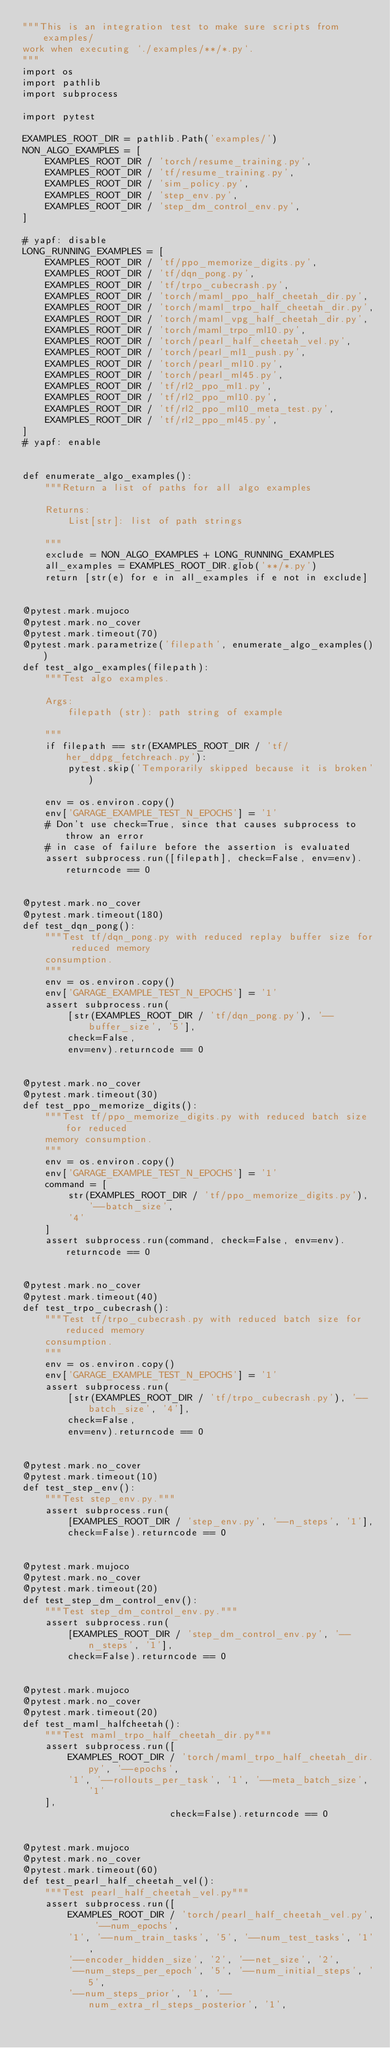<code> <loc_0><loc_0><loc_500><loc_500><_Python_>"""This is an integration test to make sure scripts from examples/
work when executing `./examples/**/*.py`.
"""
import os
import pathlib
import subprocess

import pytest

EXAMPLES_ROOT_DIR = pathlib.Path('examples/')
NON_ALGO_EXAMPLES = [
    EXAMPLES_ROOT_DIR / 'torch/resume_training.py',
    EXAMPLES_ROOT_DIR / 'tf/resume_training.py',
    EXAMPLES_ROOT_DIR / 'sim_policy.py',
    EXAMPLES_ROOT_DIR / 'step_env.py',
    EXAMPLES_ROOT_DIR / 'step_dm_control_env.py',
]

# yapf: disable
LONG_RUNNING_EXAMPLES = [
    EXAMPLES_ROOT_DIR / 'tf/ppo_memorize_digits.py',
    EXAMPLES_ROOT_DIR / 'tf/dqn_pong.py',
    EXAMPLES_ROOT_DIR / 'tf/trpo_cubecrash.py',
    EXAMPLES_ROOT_DIR / 'torch/maml_ppo_half_cheetah_dir.py',
    EXAMPLES_ROOT_DIR / 'torch/maml_trpo_half_cheetah_dir.py',
    EXAMPLES_ROOT_DIR / 'torch/maml_vpg_half_cheetah_dir.py',
    EXAMPLES_ROOT_DIR / 'torch/maml_trpo_ml10.py',
    EXAMPLES_ROOT_DIR / 'torch/pearl_half_cheetah_vel.py',
    EXAMPLES_ROOT_DIR / 'torch/pearl_ml1_push.py',
    EXAMPLES_ROOT_DIR / 'torch/pearl_ml10.py',
    EXAMPLES_ROOT_DIR / 'torch/pearl_ml45.py',
    EXAMPLES_ROOT_DIR / 'tf/rl2_ppo_ml1.py',
    EXAMPLES_ROOT_DIR / 'tf/rl2_ppo_ml10.py',
    EXAMPLES_ROOT_DIR / 'tf/rl2_ppo_ml10_meta_test.py',
    EXAMPLES_ROOT_DIR / 'tf/rl2_ppo_ml45.py',
]
# yapf: enable


def enumerate_algo_examples():
    """Return a list of paths for all algo examples

    Returns:
        List[str]: list of path strings

    """
    exclude = NON_ALGO_EXAMPLES + LONG_RUNNING_EXAMPLES
    all_examples = EXAMPLES_ROOT_DIR.glob('**/*.py')
    return [str(e) for e in all_examples if e not in exclude]


@pytest.mark.mujoco
@pytest.mark.no_cover
@pytest.mark.timeout(70)
@pytest.mark.parametrize('filepath', enumerate_algo_examples())
def test_algo_examples(filepath):
    """Test algo examples.

    Args:
        filepath (str): path string of example

    """
    if filepath == str(EXAMPLES_ROOT_DIR / 'tf/her_ddpg_fetchreach.py'):
        pytest.skip('Temporarily skipped because it is broken')

    env = os.environ.copy()
    env['GARAGE_EXAMPLE_TEST_N_EPOCHS'] = '1'
    # Don't use check=True, since that causes subprocess to throw an error
    # in case of failure before the assertion is evaluated
    assert subprocess.run([filepath], check=False, env=env).returncode == 0


@pytest.mark.no_cover
@pytest.mark.timeout(180)
def test_dqn_pong():
    """Test tf/dqn_pong.py with reduced replay buffer size for reduced memory
    consumption.
    """
    env = os.environ.copy()
    env['GARAGE_EXAMPLE_TEST_N_EPOCHS'] = '1'
    assert subprocess.run(
        [str(EXAMPLES_ROOT_DIR / 'tf/dqn_pong.py'), '--buffer_size', '5'],
        check=False,
        env=env).returncode == 0


@pytest.mark.no_cover
@pytest.mark.timeout(30)
def test_ppo_memorize_digits():
    """Test tf/ppo_memorize_digits.py with reduced batch size for reduced
    memory consumption.
    """
    env = os.environ.copy()
    env['GARAGE_EXAMPLE_TEST_N_EPOCHS'] = '1'
    command = [
        str(EXAMPLES_ROOT_DIR / 'tf/ppo_memorize_digits.py'), '--batch_size',
        '4'
    ]
    assert subprocess.run(command, check=False, env=env).returncode == 0


@pytest.mark.no_cover
@pytest.mark.timeout(40)
def test_trpo_cubecrash():
    """Test tf/trpo_cubecrash.py with reduced batch size for reduced memory
    consumption.
    """
    env = os.environ.copy()
    env['GARAGE_EXAMPLE_TEST_N_EPOCHS'] = '1'
    assert subprocess.run(
        [str(EXAMPLES_ROOT_DIR / 'tf/trpo_cubecrash.py'), '--batch_size', '4'],
        check=False,
        env=env).returncode == 0


@pytest.mark.no_cover
@pytest.mark.timeout(10)
def test_step_env():
    """Test step_env.py."""
    assert subprocess.run(
        [EXAMPLES_ROOT_DIR / 'step_env.py', '--n_steps', '1'],
        check=False).returncode == 0


@pytest.mark.mujoco
@pytest.mark.no_cover
@pytest.mark.timeout(20)
def test_step_dm_control_env():
    """Test step_dm_control_env.py."""
    assert subprocess.run(
        [EXAMPLES_ROOT_DIR / 'step_dm_control_env.py', '--n_steps', '1'],
        check=False).returncode == 0


@pytest.mark.mujoco
@pytest.mark.no_cover
@pytest.mark.timeout(20)
def test_maml_halfcheetah():
    """Test maml_trpo_half_cheetah_dir.py"""
    assert subprocess.run([
        EXAMPLES_ROOT_DIR / 'torch/maml_trpo_half_cheetah_dir.py', '--epochs',
        '1', '--rollouts_per_task', '1', '--meta_batch_size', '1'
    ],
                          check=False).returncode == 0


@pytest.mark.mujoco
@pytest.mark.no_cover
@pytest.mark.timeout(60)
def test_pearl_half_cheetah_vel():
    """Test pearl_half_cheetah_vel.py"""
    assert subprocess.run([
        EXAMPLES_ROOT_DIR / 'torch/pearl_half_cheetah_vel.py', '--num_epochs',
        '1', '--num_train_tasks', '5', '--num_test_tasks', '1',
        '--encoder_hidden_size', '2', '--net_size', '2',
        '--num_steps_per_epoch', '5', '--num_initial_steps', '5',
        '--num_steps_prior', '1', '--num_extra_rl_steps_posterior', '1',</code> 